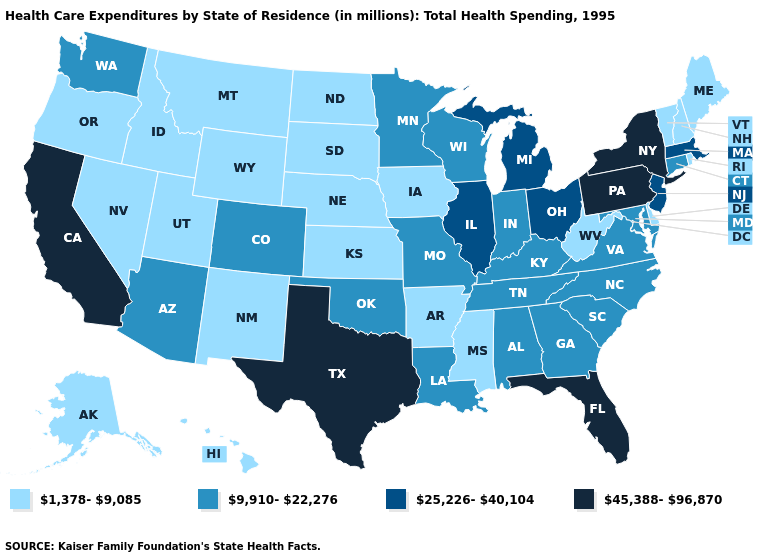Does Oklahoma have the highest value in the USA?
Short answer required. No. Which states have the lowest value in the MidWest?
Quick response, please. Iowa, Kansas, Nebraska, North Dakota, South Dakota. What is the highest value in the West ?
Short answer required. 45,388-96,870. Name the states that have a value in the range 45,388-96,870?
Write a very short answer. California, Florida, New York, Pennsylvania, Texas. Does New York have the highest value in the USA?
Quick response, please. Yes. What is the highest value in states that border Minnesota?
Keep it brief. 9,910-22,276. What is the value of Kentucky?
Keep it brief. 9,910-22,276. Does the map have missing data?
Quick response, please. No. Which states have the highest value in the USA?
Answer briefly. California, Florida, New York, Pennsylvania, Texas. Name the states that have a value in the range 25,226-40,104?
Be succinct. Illinois, Massachusetts, Michigan, New Jersey, Ohio. Does South Carolina have the lowest value in the USA?
Short answer required. No. What is the highest value in the USA?
Be succinct. 45,388-96,870. What is the value of Arkansas?
Give a very brief answer. 1,378-9,085. Name the states that have a value in the range 1,378-9,085?
Concise answer only. Alaska, Arkansas, Delaware, Hawaii, Idaho, Iowa, Kansas, Maine, Mississippi, Montana, Nebraska, Nevada, New Hampshire, New Mexico, North Dakota, Oregon, Rhode Island, South Dakota, Utah, Vermont, West Virginia, Wyoming. Among the states that border Virginia , which have the highest value?
Give a very brief answer. Kentucky, Maryland, North Carolina, Tennessee. 